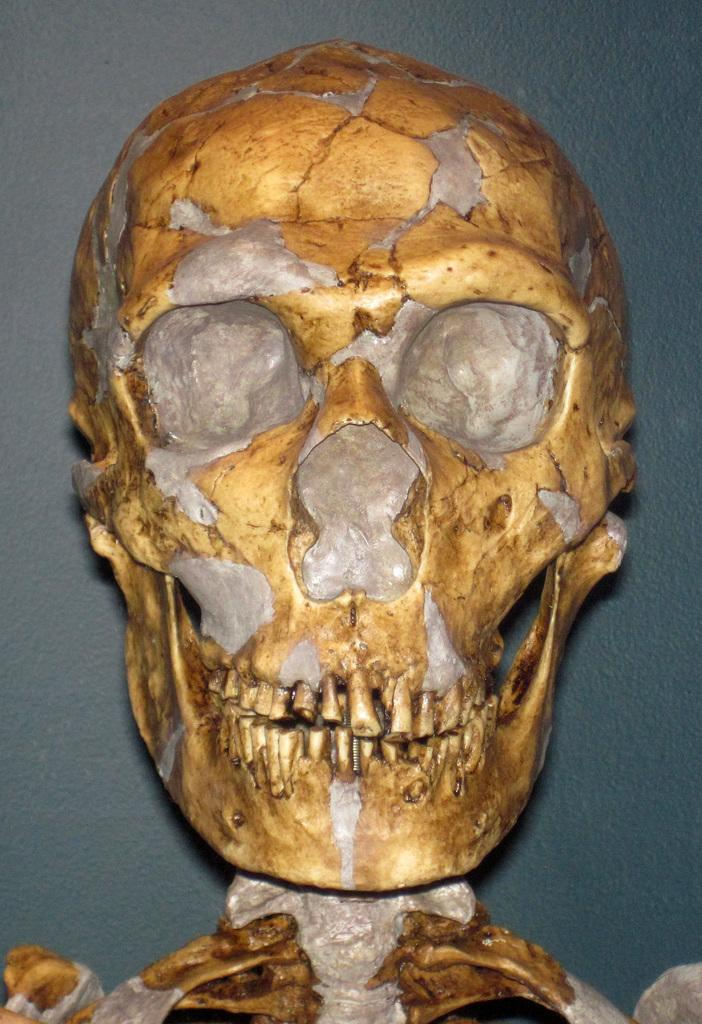What is the main subject of the image? There is a skeleton in the image. What colors are used for the skeleton? The skeleton is in gold and silver color. What can be seen in the background of the image? There is a wall in the background of the image. Is there a ball being used in a fight between the skeleton and someone else in the image? There is no ball or fight present in the image; it only features a gold and silver skeleton with a wall in the background. 